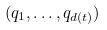<formula> <loc_0><loc_0><loc_500><loc_500>( q _ { 1 } , \dots , q _ { d ( t ) } )</formula> 